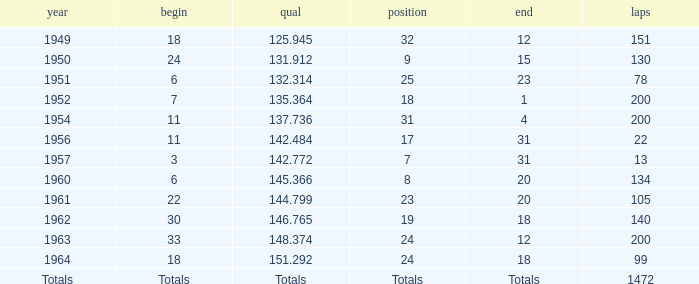Name the rank with laps of 200 and qual of 148.374 24.0. 